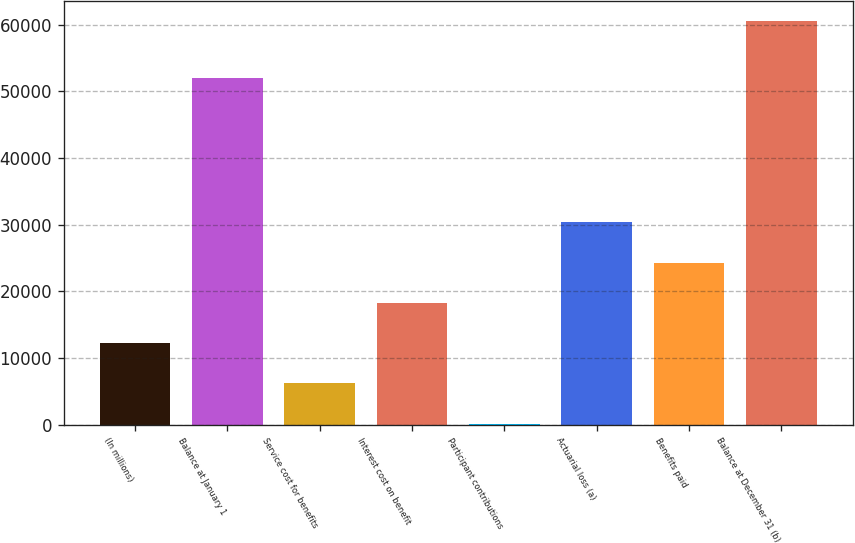Convert chart. <chart><loc_0><loc_0><loc_500><loc_500><bar_chart><fcel>(In millions)<fcel>Balance at January 1<fcel>Service cost for benefits<fcel>Interest cost on benefit<fcel>Participant contributions<fcel>Actuarial loss (a)<fcel>Benefits paid<fcel>Balance at December 31 (b)<nl><fcel>12235.6<fcel>51999<fcel>6201.3<fcel>18269.9<fcel>167<fcel>30338.5<fcel>24304.2<fcel>60510<nl></chart> 